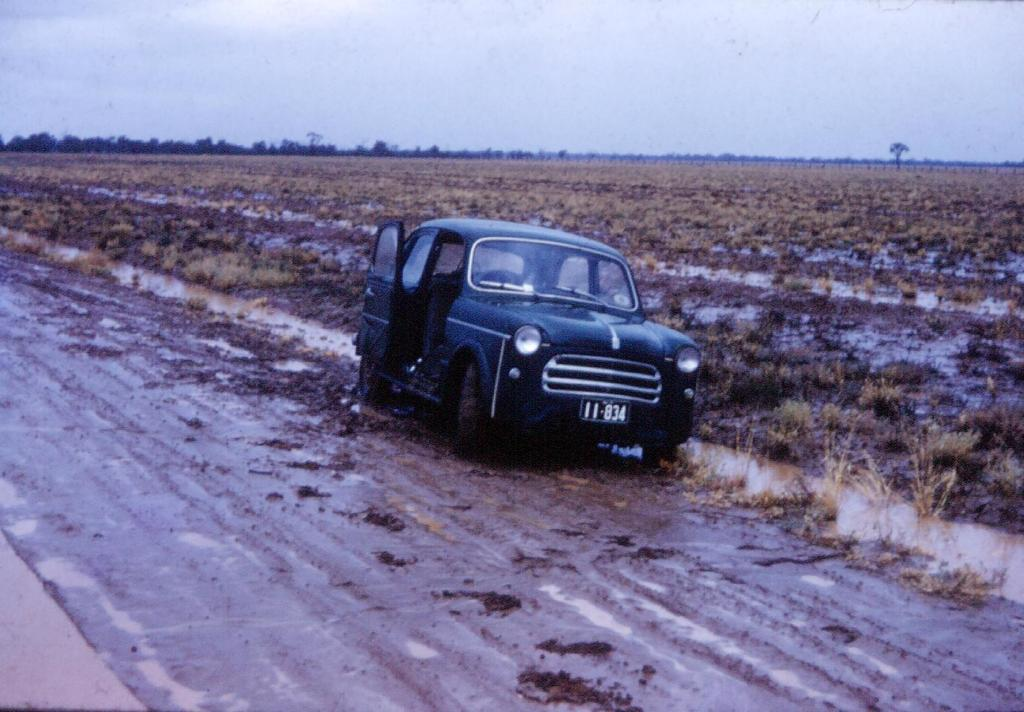What is the main subject of the image? The main subject of the image is a car on the road. What is the condition of the road in the image? The road has muddy water on it. What type of landscape can be seen in the image? Farmland is visible in the image. What other natural elements are present in the image? Trees are present in the image. What can be seen in the background of the image? The sky is visible in the background of the image. How many family members are visible in the image? There are no family members present in the image; it features a car on a muddy road with farmland and trees in the background. What type of comparison can be made between the car and the foot in the image? There is no foot present in the image, so no comparison can be made. 